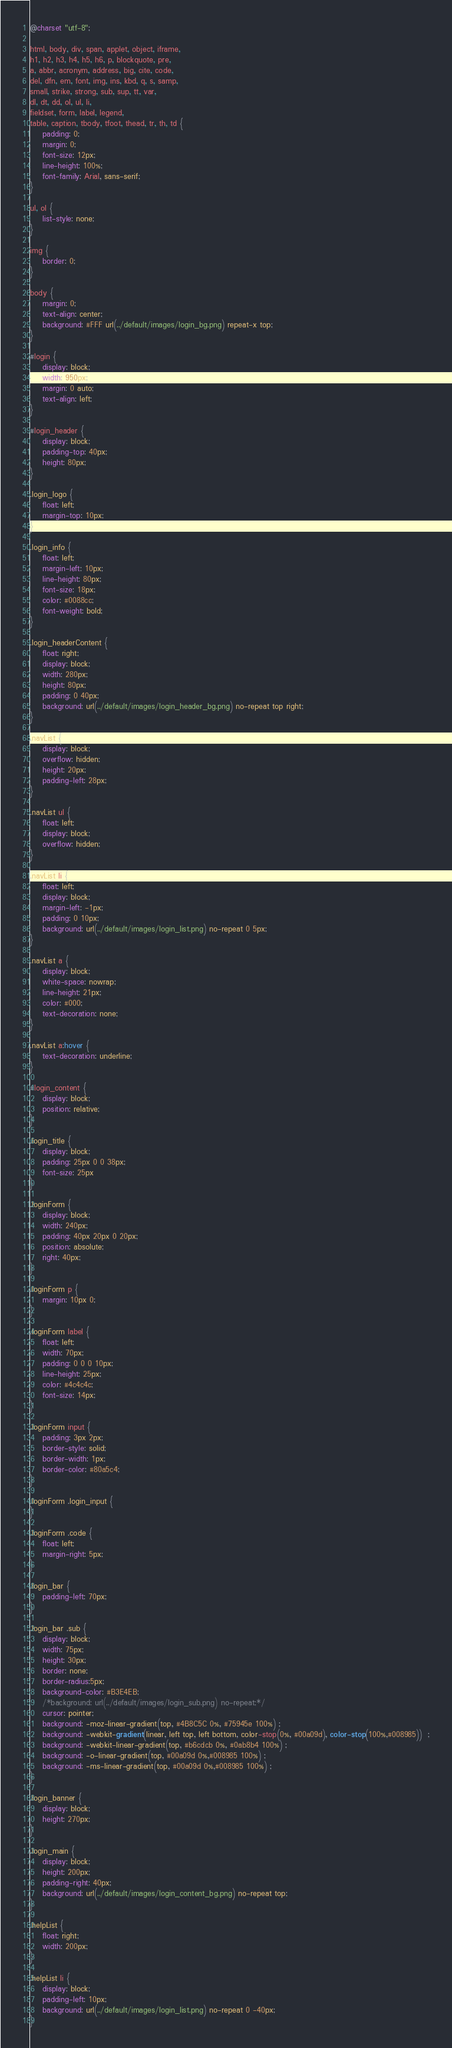<code> <loc_0><loc_0><loc_500><loc_500><_CSS_>@charset "utf-8";

html, body, div, span, applet, object, iframe,
h1, h2, h3, h4, h5, h6, p, blockquote, pre,
a, abbr, acronym, address, big, cite, code,
del, dfn, em, font, img, ins, kbd, q, s, samp,
small, strike, strong, sub, sup, tt, var,
dl, dt, dd, ol, ul, li,
fieldset, form, label, legend,
table, caption, tbody, tfoot, thead, tr, th, td {
    padding: 0;
    margin: 0;
    font-size: 12px;
    line-height: 100%;
    font-family: Arial, sans-serif;
}

ul, ol {
    list-style: none;
}

img {
    border: 0;
}

body {
    margin: 0;
    text-align: center;
    background: #FFF url(../default/images/login_bg.png) repeat-x top;
}

#login {
    display: block;
    width: 950px;
    margin: 0 auto;
    text-align: left;
}

#login_header {
    display: block;
    padding-top: 40px;
    height: 80px;
}

.login_logo {
    float: left;
    margin-top: 10px;
}

.login_info {
    float: left;
    margin-left: 10px;
    line-height: 80px;
    font-size: 18px;
    color: #0088cc;
    font-weight: bold;
}

.login_headerContent {
    float: right;
    display: block;
    width: 280px;
    height: 80px;
    padding: 0 40px;
    background: url(../default/images/login_header_bg.png) no-repeat top right;
}

.navList {
    display: block;
    overflow: hidden;
    height: 20px;
    padding-left: 28px;
}

.navList ul {
    float: left;
    display: block;
    overflow: hidden;
}

.navList li {
    float: left;
    display: block;
    margin-left: -1px;
    padding: 0 10px;
    background: url(../default/images/login_list.png) no-repeat 0 5px;
}

.navList a {
    display: block;
    white-space: nowrap;
    line-height: 21px;
    color: #000;
    text-decoration: none;
}

.navList a:hover {
    text-decoration: underline;
}

#login_content {
    display: block;
    position: relative;
}

.login_title {
    display: block;
    padding: 25px 0 0 38px;
    font-size: 25px
}

.loginForm {
    display: block;
    width: 240px;
    padding: 40px 20px 0 20px;
    position: absolute;
    right: 40px;
}

.loginForm p {
    margin: 10px 0;
}

.loginForm label {
    float: left;
    width: 70px;
    padding: 0 0 0 10px;
    line-height: 25px;
    color: #4c4c4c;
    font-size: 14px;
}

.loginForm input {
    padding: 3px 2px;
    border-style: solid;
    border-width: 1px;
    border-color: #80a5c4;
}

.loginForm .login_input {
}

.loginForm .code {
    float: left;
    margin-right: 5px;
}

.login_bar {
    padding-left: 70px;
}

.login_bar .sub {
    display: block;
    width: 75px;
    height: 30px;
    border: none;
    border-radius:5px;
    background-color: #B3E4EB;
    /*background: url(../default/images/login_sub.png) no-repeat;*/
    cursor: pointer;
    background: -moz-linear-gradient(top, #4B8C5C 0%, #75945e 100%) ;
    background: -webkit-gradient(linear, left top, left bottom, color-stop(0%, #00a09d), color-stop(100%,#008985))  ;
    background: -webkit-linear-gradient(top, #b6cdcb 0%, #0ab8b4 100%) ;
    background: -o-linear-gradient(top, #00a09d 0%,#008985 100%) ;
    background: -ms-linear-gradient(top, #00a09d 0%,#008985 100%) ;
}

.login_banner {
    display: block;
    height: 270px;
}

.login_main {
    display: block;
    height: 200px;
    padding-right: 40px;
    background: url(../default/images/login_content_bg.png) no-repeat top;
}

.helpList {
    float: right;
    width: 200px;
}

.helpList li {
    display: block;
    padding-left: 10px;
    background: url(../default/images/login_list.png) no-repeat 0 -40px;
}
</code> 